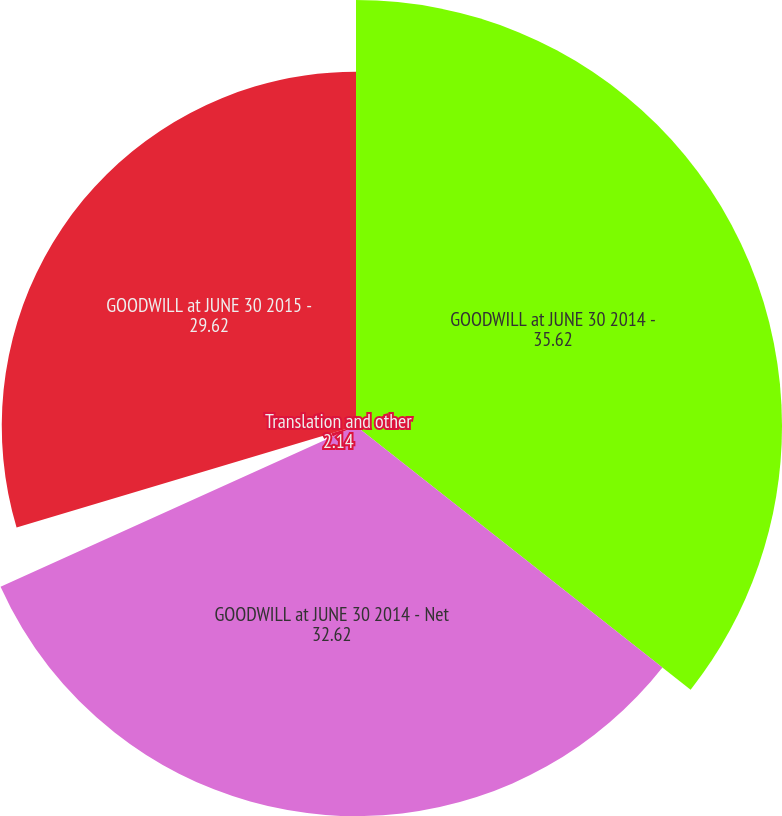Convert chart. <chart><loc_0><loc_0><loc_500><loc_500><pie_chart><fcel>GOODWILL at JUNE 30 2014 -<fcel>GOODWILL at JUNE 30 2014 - Net<fcel>Translation and other<fcel>GOODWILL at JUNE 30 2015 -<nl><fcel>35.62%<fcel>32.62%<fcel>2.14%<fcel>29.62%<nl></chart> 